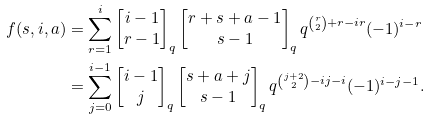Convert formula to latex. <formula><loc_0><loc_0><loc_500><loc_500>f ( s , i , a ) & = \sum _ { r = 1 } ^ { i } \begin{bmatrix} i - 1 \\ r - 1 \end{bmatrix} _ { q } \begin{bmatrix} r + s + a - 1 \\ s - 1 \end{bmatrix} _ { q } q ^ { \binom { r } { 2 } + r - i r } ( - 1 ) ^ { i - r } \\ & = \sum _ { j = 0 } ^ { i - 1 } \begin{bmatrix} i - 1 \\ j \end{bmatrix} _ { q } \begin{bmatrix} s + a + j \\ s - 1 \end{bmatrix} _ { q } q ^ { \binom { j + 2 } { 2 } - i j - i } ( - 1 ) ^ { i - j - 1 } .</formula> 